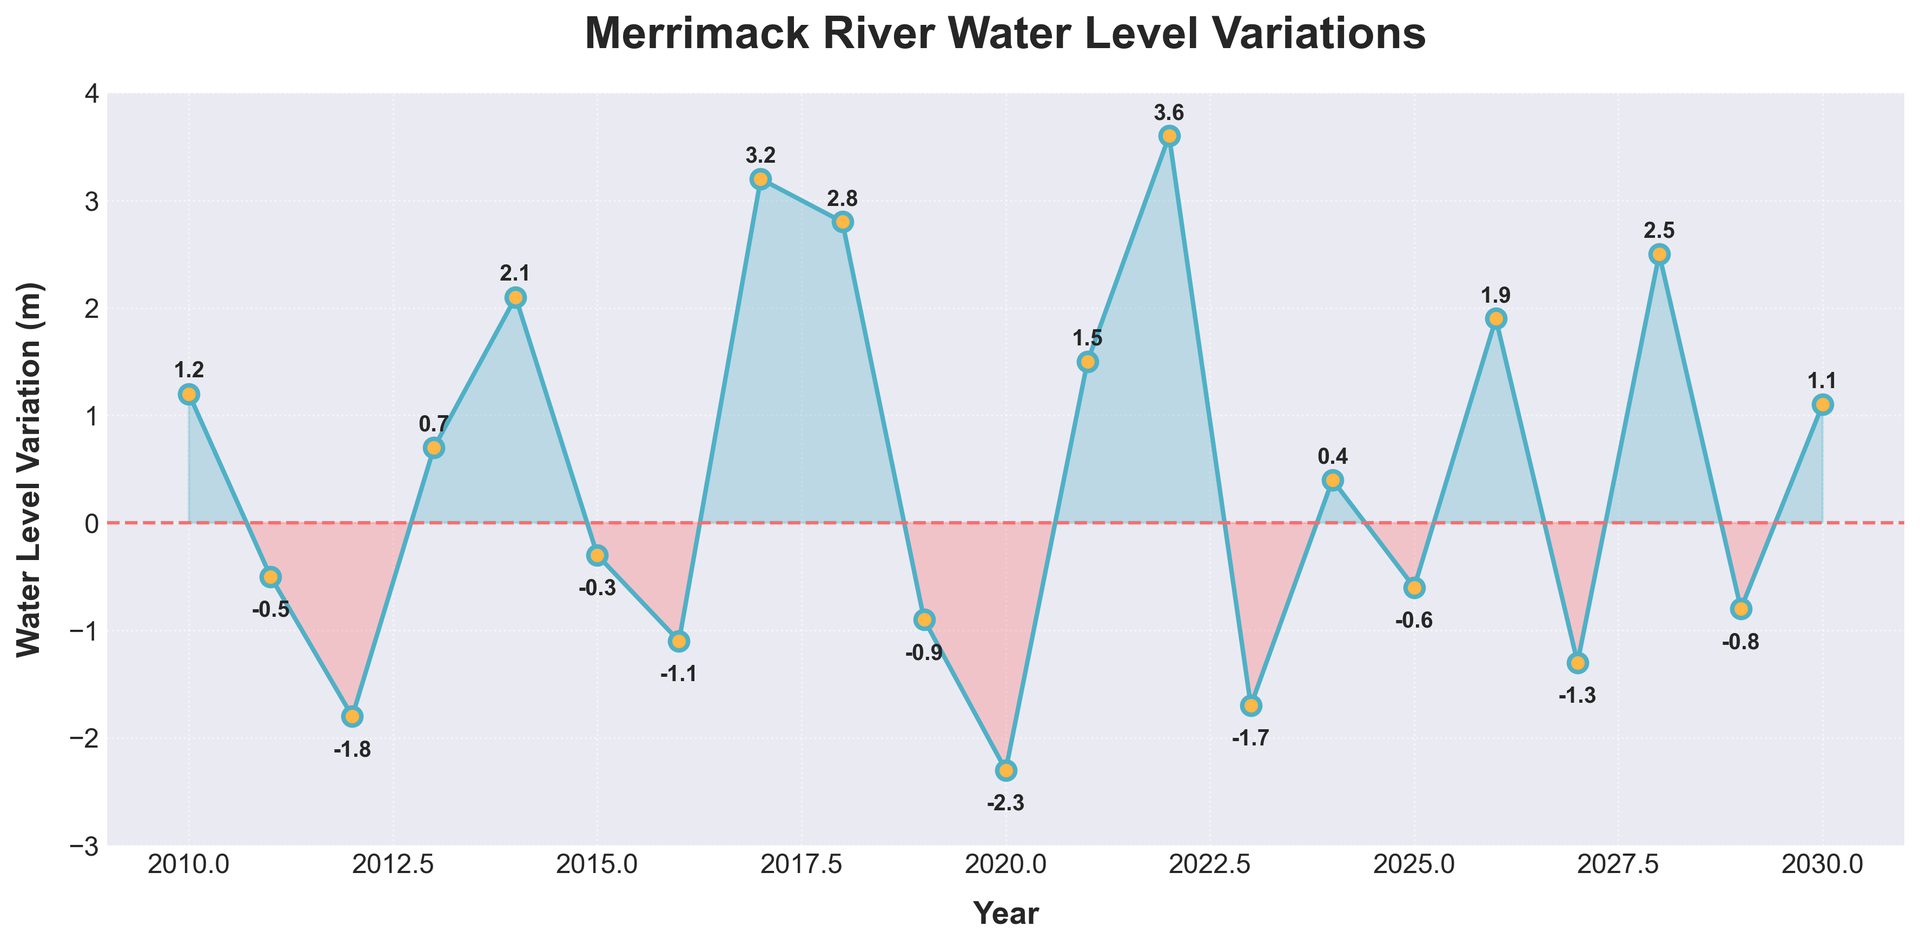What was the highest water level variation recorded? The highest point on the line chart represents the maximum water level variation. It occurred in 2022 with a value of 3.6 meters.
Answer: 3.6 meters In which year did the river experience the lowest water level variation? The lowest point on the line chart signifies the minimum water level variation. It happened in 2020 with a variation of -2.3 meters.
Answer: 2020 What is the difference between the highest and lowest water level variations? To find the difference, subtract the lowest value (-2.3 meters) from the highest value (3.6 meters). The calculation would be 3.6 - (-2.3) = 3.6 + 2.3 = 5.9 meters.
Answer: 5.9 meters How many years experienced a positive water level variation? Count the number of years represented by points above the horizontal zero line. The years with positive variations are: 2010, 2013, 2014, 2017, 2018, 2021, 2022, 2024, 2026, 2028, and 2030 which gives us 11 years.
Answer: 11 years Between 2015 and 2020, which year had the highest positive water level variation? Look between the years 2015 and 2020 and identify the highest point within this range. The year 2020 had the highest positive variation of 1.5 meters.
Answer: 2021 Which periods experienced a continuous increase in water level variations over the years? Identify the consecutive years where the line is trending upward without dropping. Such periods are 2016-2018, and 2024-2026.
Answer: 2016-2018 and 2024-2026 How many times did the water level variation cross below zero between 2010 and 2030? Count the number of times the line crosses the horizontal line at zero, indicating a change from positive to negative or vice versa. It crossed zero 7 times: after 2010, 2014, 2017, 2021, 2024, 2026, and 2028.
Answer: 7 times In which years were the water level variations in the negative range? Identify the years where the points lie below the zero line. These are: 2011, 2012, 2015, 2016, 2019, 2020, 2023, 2025, 2027, 2029.
Answer: 2011, 2012, 2015, 2016, 2019, 2020, 2023, 2025, 2027, 2029 